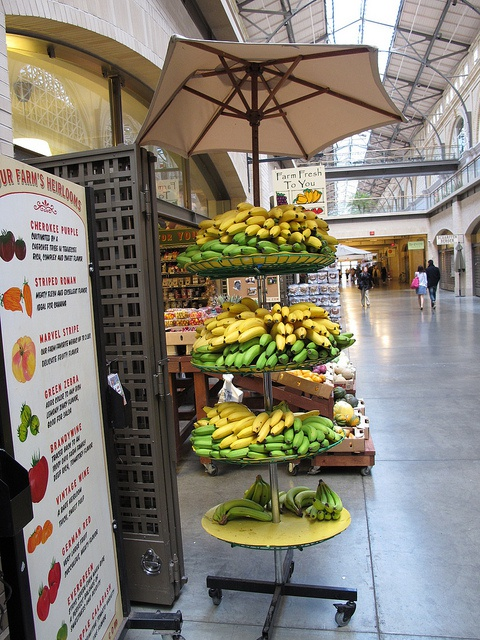Describe the objects in this image and their specific colors. I can see umbrella in darkgray, gray, and black tones, banana in darkgray, khaki, and olive tones, banana in darkgray, olive, and gold tones, banana in darkgray, khaki, olive, and gold tones, and banana in darkgray, lightgreen, black, darkgreen, and olive tones in this image. 